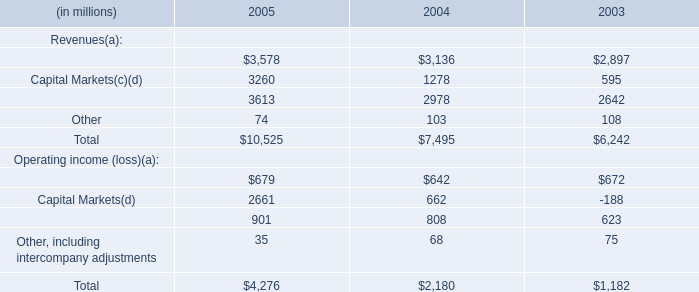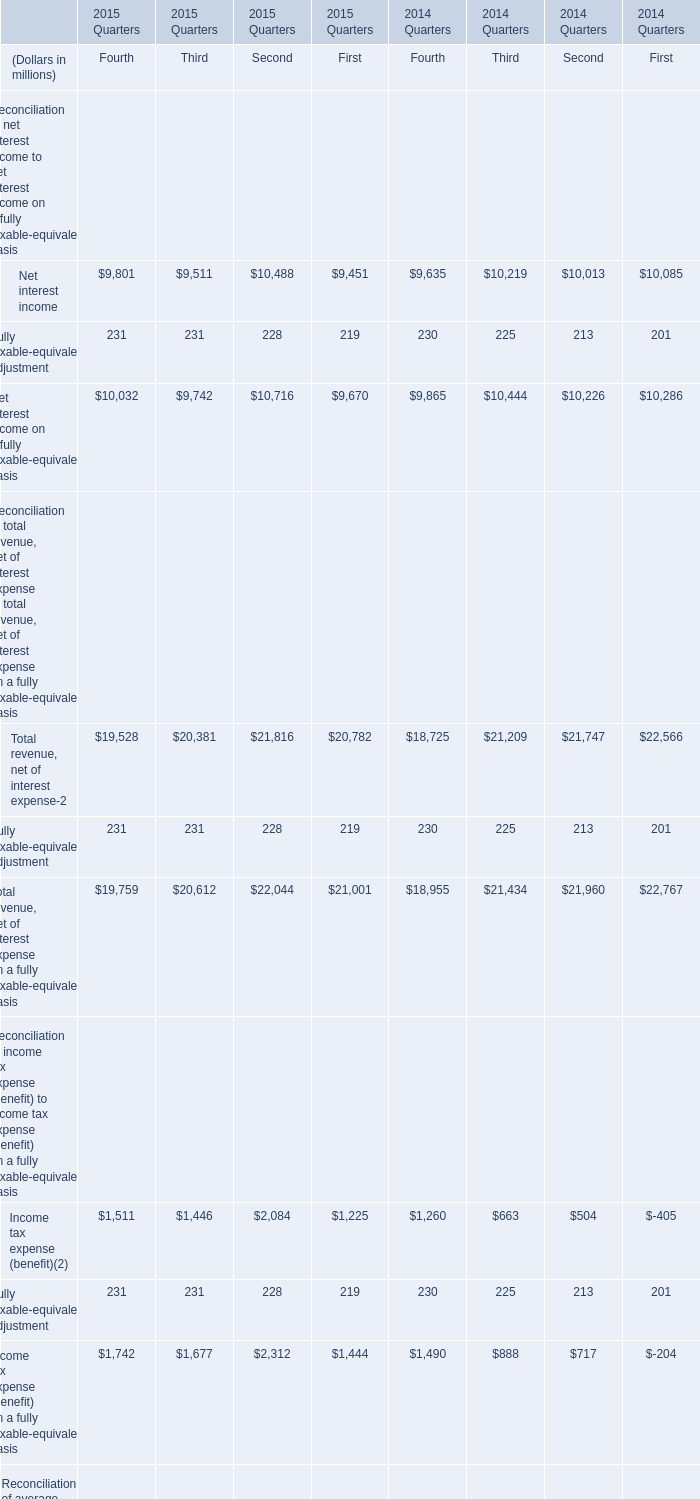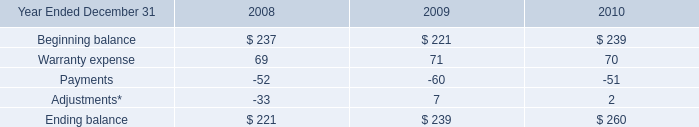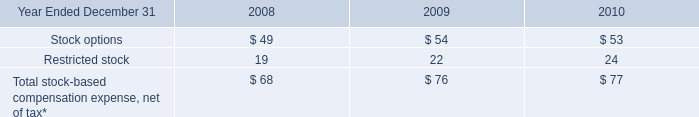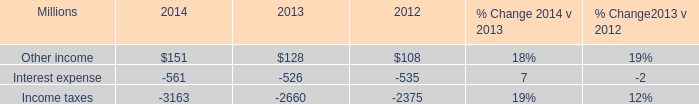What's the sum of Net interest income of 2015 Quarters Fourth, and Aircraft Finance of 2004 ? 
Computations: (9801.0 + 3136.0)
Answer: 12937.0. 